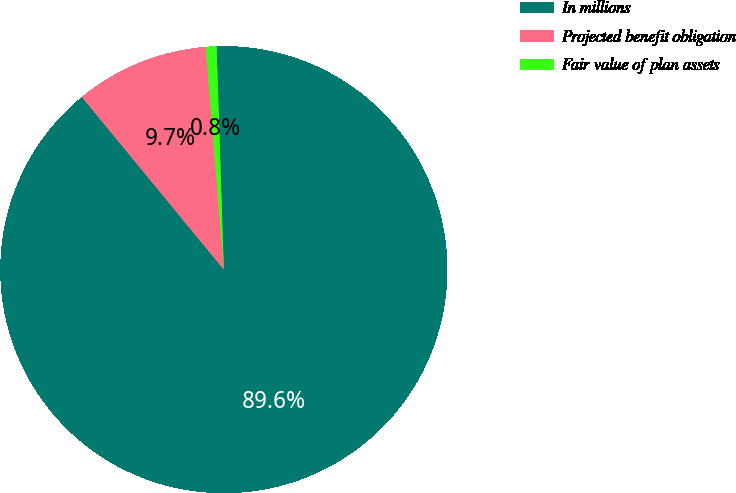Convert chart. <chart><loc_0><loc_0><loc_500><loc_500><pie_chart><fcel>In millions<fcel>Projected benefit obligation<fcel>Fair value of plan assets<nl><fcel>89.57%<fcel>9.66%<fcel>0.78%<nl></chart> 